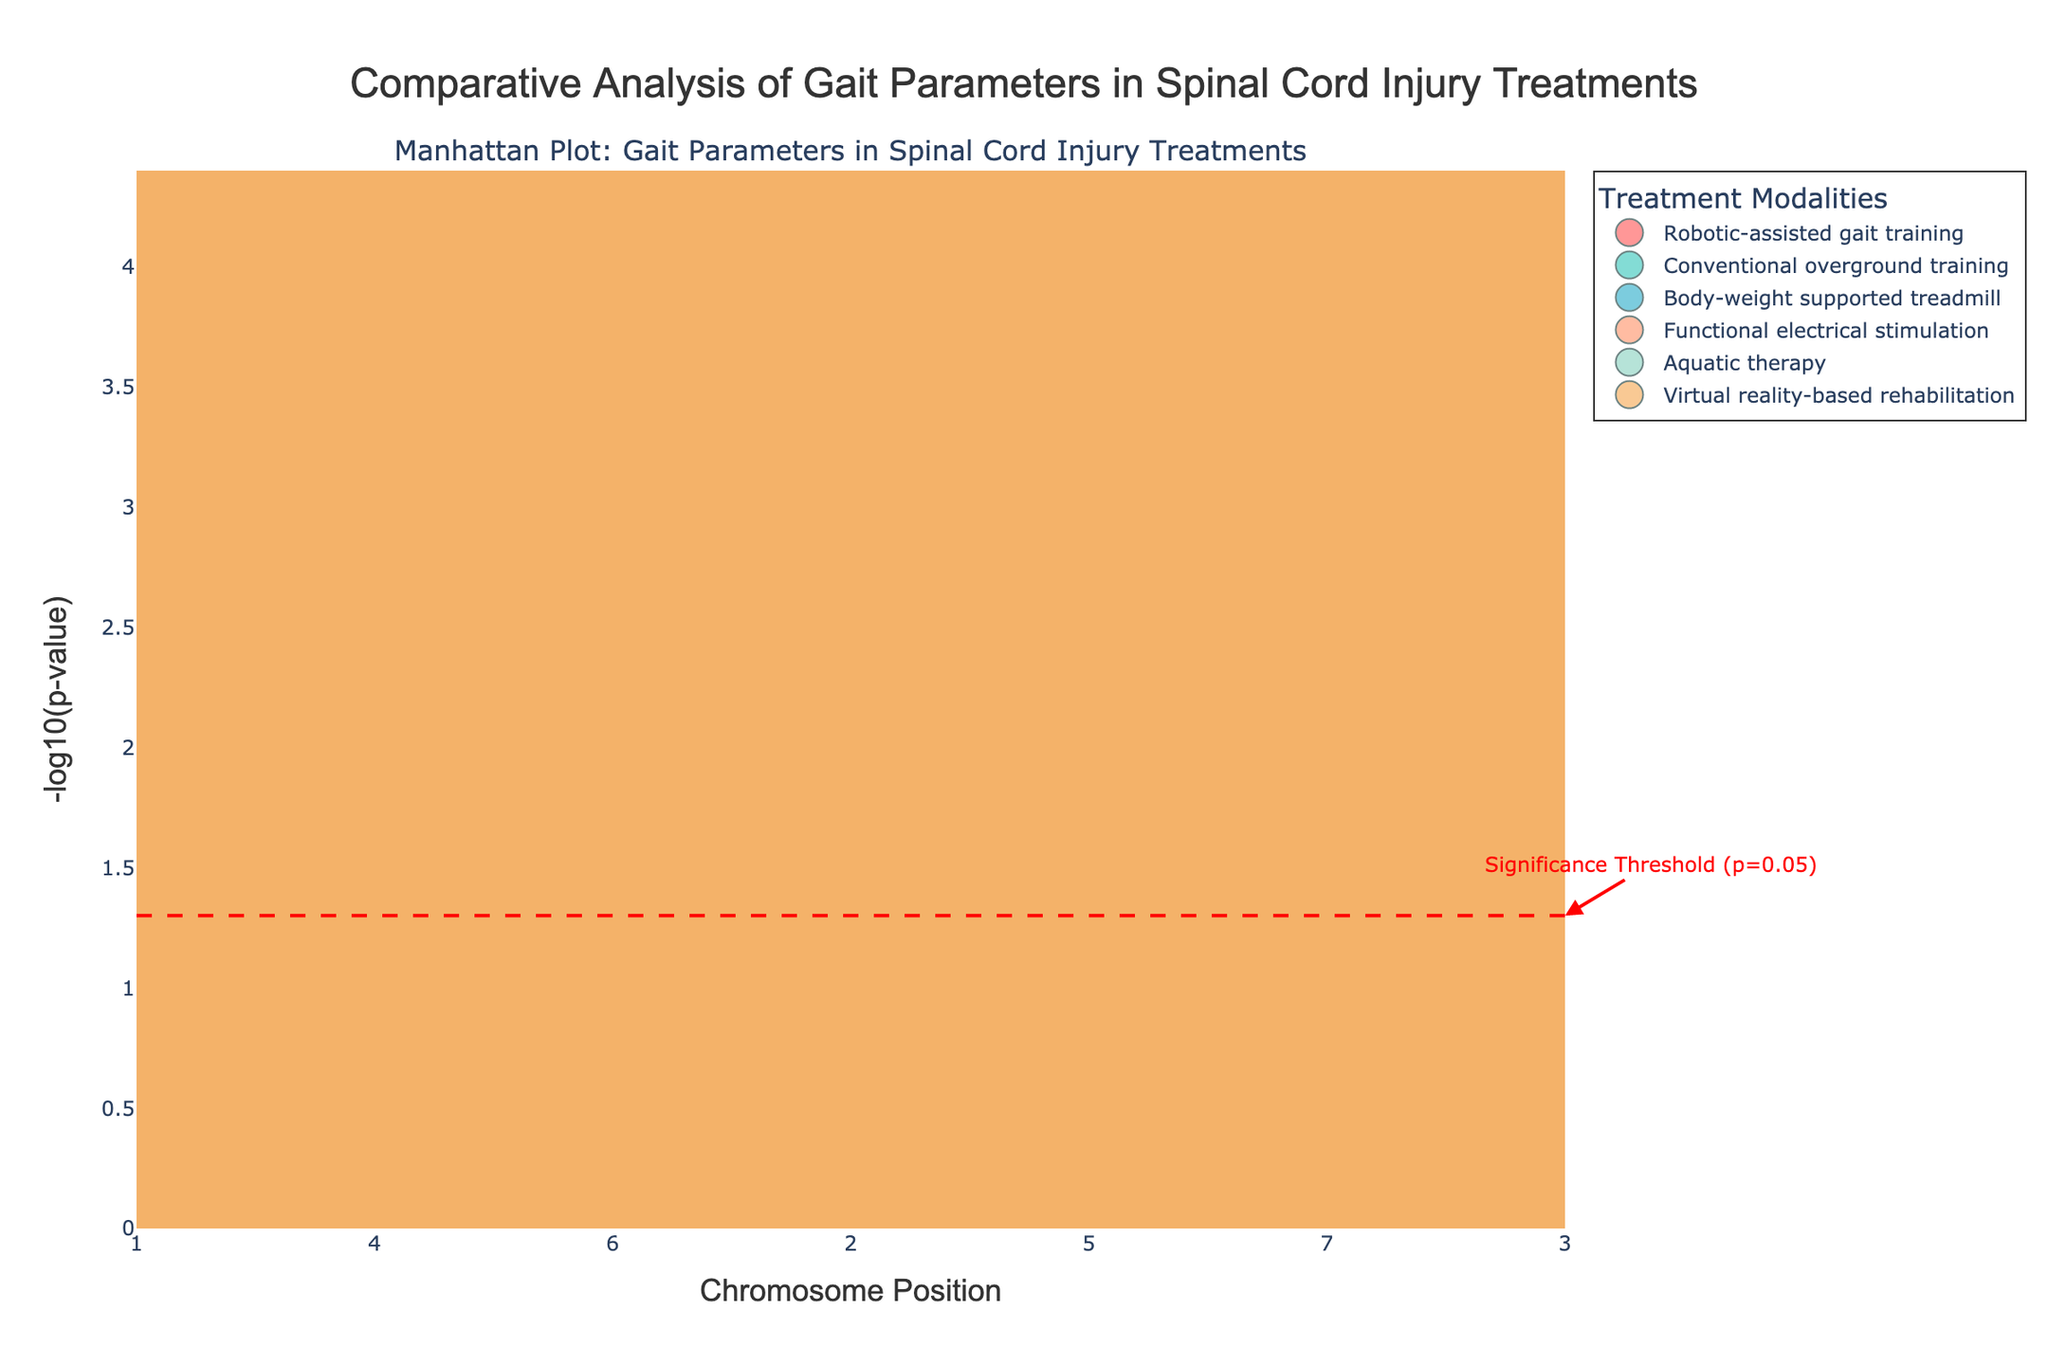What is the title of the plot? The title is prominently displayed at the top-center of the plot. It reads "Comparative Analysis of Gait Parameters in Spinal Cord Injury Treatments".
Answer: Comparative Analysis of Gait Parameters in Spinal Cord Injury Treatments How many different treatments are compared in the plot? The legend on the plot lists all the treatment modalities. There are six distinct treatments shown: Robotic-assisted gait training, Conventional overground training, Body-weight supported treadmill, Functional electrical stimulation, Aquatic therapy, and Virtual reality-based rehabilitation.
Answer: 6 Which treatment modality has the lowest p-value on chromosome 1? By looking at the y-axis which represents -log10(p-value), the lowest p-value will have the highest -log10(p-value). On chromosome 1, the highest point corresponds to Body-weight supported treadmill at position 4000000.
Answer: Body-weight supported treadmill What is the significance threshold p-value in terms of -log10(p-value)? The red dashed horizontal line indicates the significance threshold. It's annotated with the text "Significance Threshold (p=0.05)", so we need to convert p = 0.05 into -log10(p), which equals approximately 1.3.
Answer: ~1.3 Which treatment(s) have data points that exceed the significance threshold? Points that exceed the significance threshold line (y > 1.3) on the plot are: Robotic-assisted gait training (positions 1000000, 3000000, 3500000 on different chromosomes), Body-weight supported treadmill (1000000 on chromosome 4), and Functional electrical stimulation (1500000 on chromosome 5).
Answer: Robotic-assisted gait training, Body-weight supported treadmill, Functional electrical stimulation Compare the p-values of Body-weight supported treadmill at positions 1000000 on chromosome 4 and 2500000 on chromosome 7. Which one is smaller? The y-axis shows -log10(p-value), so the larger the value, the smaller the p-value. At position 1000000 on chromosome 4, the -log10(p) is higher than at 2500000 on chromosome 7. Therefore, the p-value at position 1000000 on chromosome 4 is smaller.
Answer: Position 1000000 on chromosome 4 Which treatment modality has the most significant improvement in gait parameters overall? This can be interpreted by identifying which treatment has the most data points above the significance threshold (y > 1.3). Robotic-assisted gait training has the most data points exceeding this threshold.
Answer: Robotic-assisted gait training How many data points are there for each treatment modality? By counting the data points for each treatment in the plot or by checking the unique treatments and their frequency in the dataset. The result is:
Robotic-assisted gait training: 4
Conventional overground training: 3
Body-weight supported treadmill: 3
Functional electrical stimulation: 3
Aquatic therapy: 3
Virtual reality-based rehabilitation: 3
Answer: 4, 3, 3, 3, 3, 3 What is the position of the most significant p-value for Robotic-assisted gait training? The most significant p-value will have the highest corresponding -log10(p-value) on the y-axis. For Robotic-assisted gait training, this is at position 3500000 on chromosome 9 with the highest point.
Answer: 3500000 on chromosome 9 